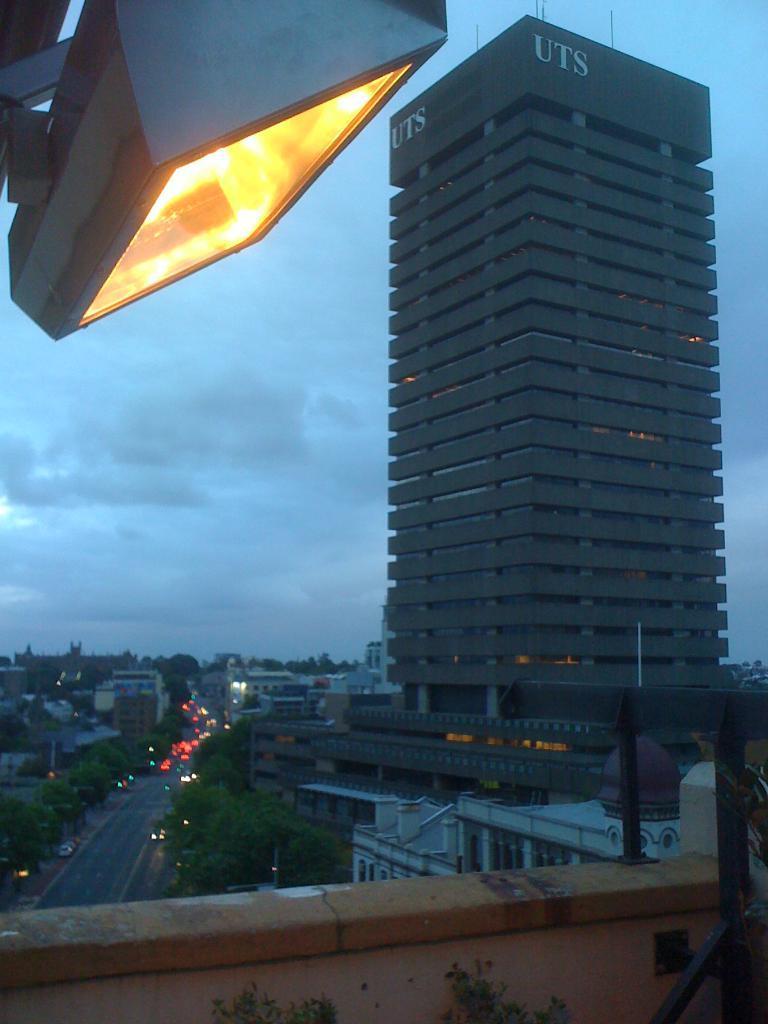Please provide a concise description of this image. In this image I can see a terrace, buildings, trees, houses and fleets of vehicles on the road. In the background I can see the sky. This image is taken may be in the evening. 